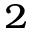<formula> <loc_0><loc_0><loc_500><loc_500>{ _ { 2 } }</formula> 